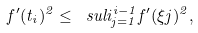Convert formula to latex. <formula><loc_0><loc_0><loc_500><loc_500>f ^ { \prime } ( t _ { i } ) ^ { 2 } \leq \ s u l i _ { j = 1 } ^ { i - 1 } f ^ { \prime } ( \xi j ) ^ { 2 } ,</formula> 